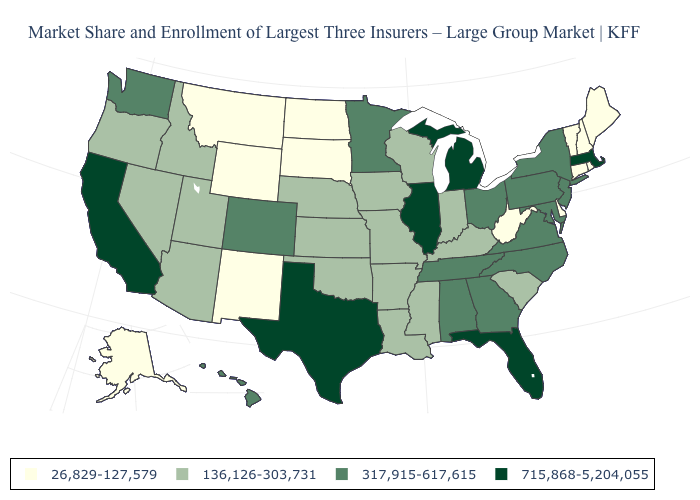Name the states that have a value in the range 26,829-127,579?
Quick response, please. Alaska, Connecticut, Delaware, Maine, Montana, New Hampshire, New Mexico, North Dakota, Rhode Island, South Dakota, Vermont, West Virginia, Wyoming. What is the value of Virginia?
Keep it brief. 317,915-617,615. Does South Dakota have the lowest value in the MidWest?
Write a very short answer. Yes. What is the value of Arizona?
Concise answer only. 136,126-303,731. Among the states that border Virginia , which have the highest value?
Write a very short answer. Maryland, North Carolina, Tennessee. Name the states that have a value in the range 26,829-127,579?
Be succinct. Alaska, Connecticut, Delaware, Maine, Montana, New Hampshire, New Mexico, North Dakota, Rhode Island, South Dakota, Vermont, West Virginia, Wyoming. Does Minnesota have a higher value than Kentucky?
Be succinct. Yes. Name the states that have a value in the range 317,915-617,615?
Quick response, please. Alabama, Colorado, Georgia, Hawaii, Maryland, Minnesota, New Jersey, New York, North Carolina, Ohio, Pennsylvania, Tennessee, Virginia, Washington. What is the value of New Mexico?
Quick response, please. 26,829-127,579. Name the states that have a value in the range 26,829-127,579?
Be succinct. Alaska, Connecticut, Delaware, Maine, Montana, New Hampshire, New Mexico, North Dakota, Rhode Island, South Dakota, Vermont, West Virginia, Wyoming. Which states hav the highest value in the West?
Answer briefly. California. Does California have the highest value in the West?
Concise answer only. Yes. Name the states that have a value in the range 317,915-617,615?
Quick response, please. Alabama, Colorado, Georgia, Hawaii, Maryland, Minnesota, New Jersey, New York, North Carolina, Ohio, Pennsylvania, Tennessee, Virginia, Washington. Which states hav the highest value in the Northeast?
Short answer required. Massachusetts. 